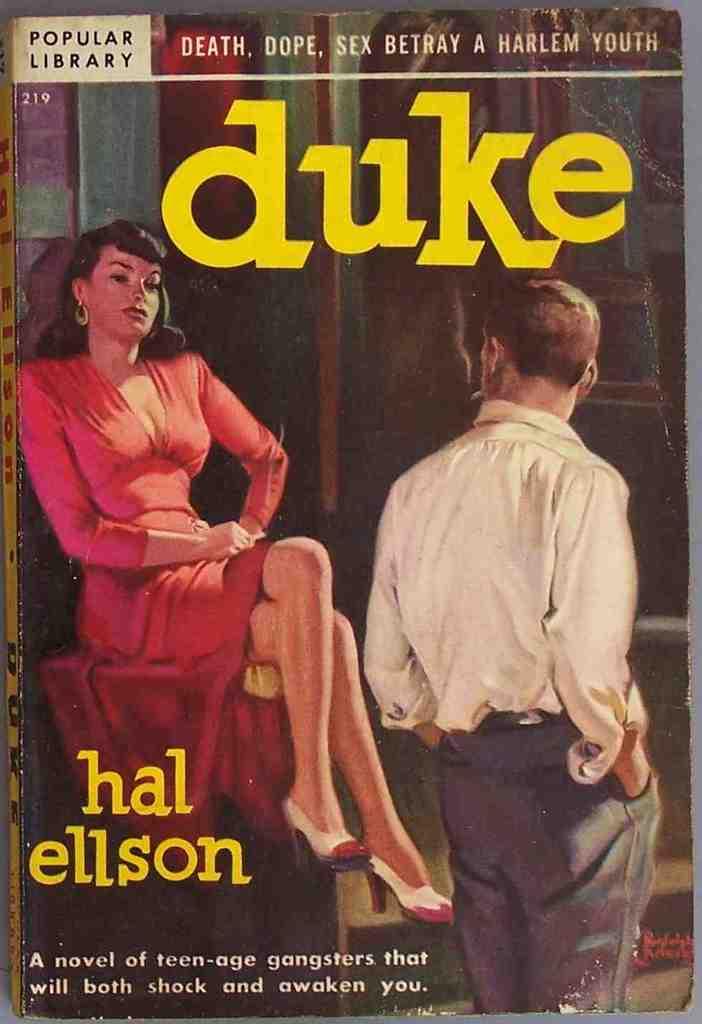Who wrote the novel "duke"?
Offer a terse response. Hal ellson. What does the book say it is about at the top?
Offer a very short reply. Death, dope, sex betray a harlem youth. 